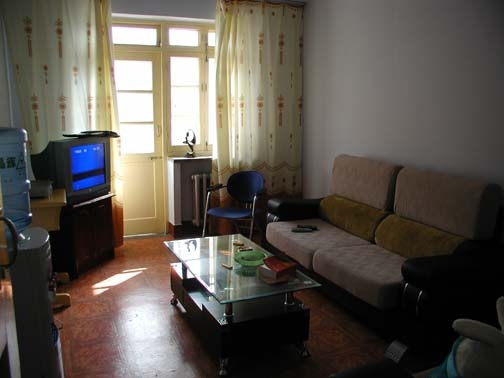Describe the objects in this image and their specific colors. I can see couch in black and gray tones, tv in black, blue, navy, and gray tones, chair in black and gray tones, chair in black, navy, gray, and maroon tones, and book in black, maroon, gray, and darkgreen tones in this image. 